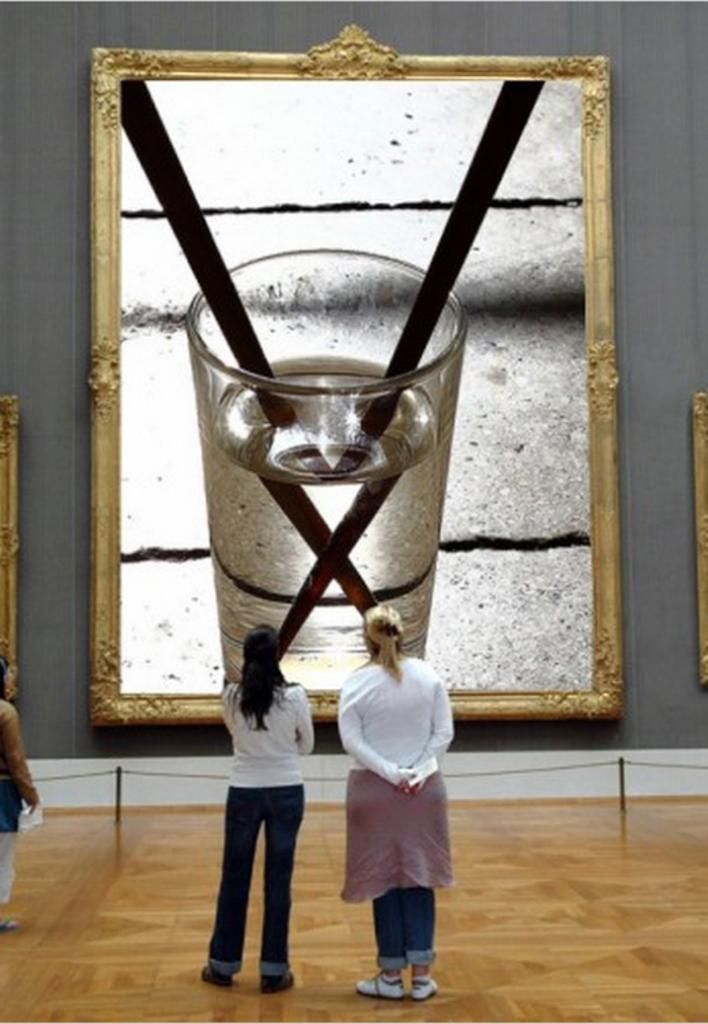How many people are present in the image? There are three persons standing in the image. What are the persons looking at? The persons are looking at a photo frame. What is inside the photo frame? The photo frame contains a glass of drink. What can be seen in the background of the image? There is a wall in the background of the image. What type of stamp is on the calendar in the image? There is no stamp or calendar present in the image. 